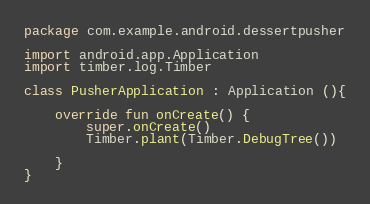Convert code to text. <code><loc_0><loc_0><loc_500><loc_500><_Kotlin_>package com.example.android.dessertpusher

import android.app.Application
import timber.log.Timber

class PusherApplication : Application (){

    override fun onCreate() {
        super.onCreate()
        Timber.plant(Timber.DebugTree())

    }
}</code> 